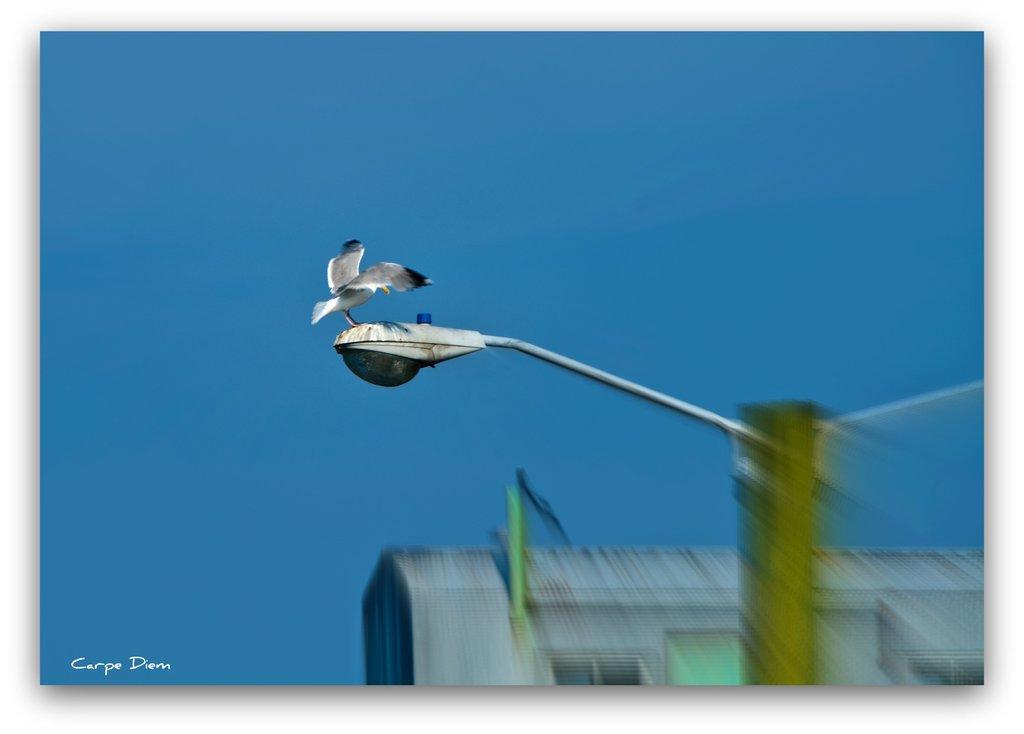What type of animal can be seen in the image? There is a bird in the image. Where is the bird located? The bird is standing on a street light. What can be seen in the background of the image? There is a building and the sky visible in the background of the image. What type of invention is the bird using to fly in the image? The bird does not need an invention to fly, as birds have their own natural ability to fly. 